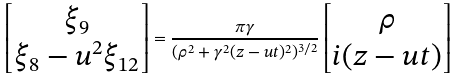Convert formula to latex. <formula><loc_0><loc_0><loc_500><loc_500>\begin{bmatrix} \xi _ { 9 } \\ \xi _ { 8 } - u ^ { 2 } \xi _ { 1 2 } \end{bmatrix} = \frac { \pi \gamma } { ( \rho ^ { 2 } + \gamma ^ { 2 } ( z - u t ) ^ { 2 } ) ^ { 3 / 2 } } \begin{bmatrix} \rho \\ i ( z - u t ) \end{bmatrix}</formula> 